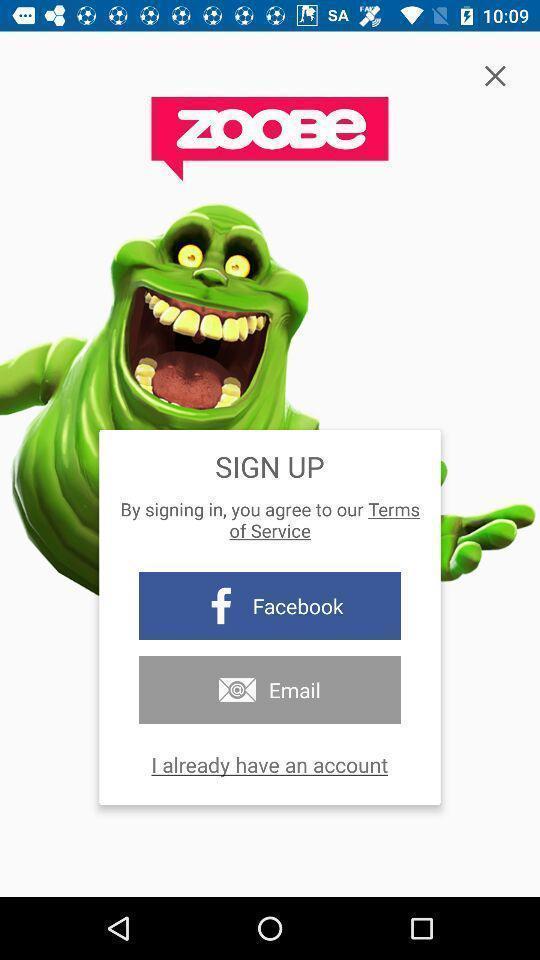Please provide a description for this image. Sign up page. 